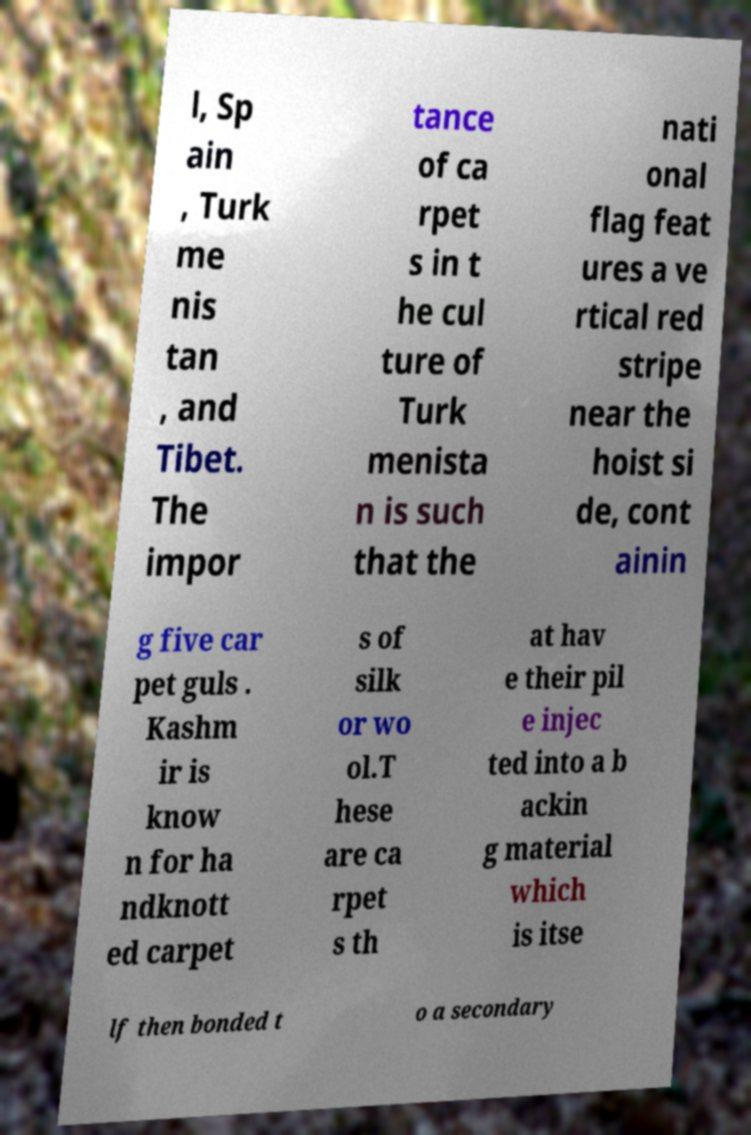Please identify and transcribe the text found in this image. l, Sp ain , Turk me nis tan , and Tibet. The impor tance of ca rpet s in t he cul ture of Turk menista n is such that the nati onal flag feat ures a ve rtical red stripe near the hoist si de, cont ainin g five car pet guls . Kashm ir is know n for ha ndknott ed carpet s of silk or wo ol.T hese are ca rpet s th at hav e their pil e injec ted into a b ackin g material which is itse lf then bonded t o a secondary 